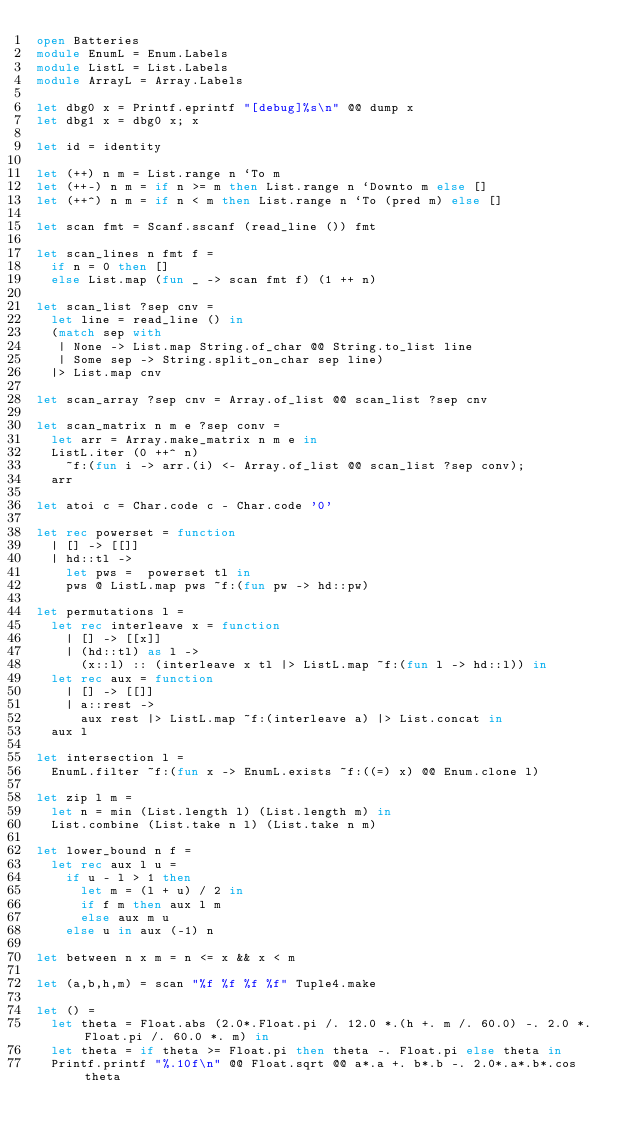Convert code to text. <code><loc_0><loc_0><loc_500><loc_500><_OCaml_>open Batteries
module EnumL = Enum.Labels
module ListL = List.Labels
module ArrayL = Array.Labels

let dbg0 x = Printf.eprintf "[debug]%s\n" @@ dump x
let dbg1 x = dbg0 x; x

let id = identity

let (++) n m = List.range n `To m
let (++-) n m = if n >= m then List.range n `Downto m else []
let (++^) n m = if n < m then List.range n `To (pred m) else []

let scan fmt = Scanf.sscanf (read_line ()) fmt

let scan_lines n fmt f =
  if n = 0 then []
  else List.map (fun _ -> scan fmt f) (1 ++ n)

let scan_list ?sep cnv =
  let line = read_line () in
  (match sep with
   | None -> List.map String.of_char @@ String.to_list line
   | Some sep -> String.split_on_char sep line)
  |> List.map cnv

let scan_array ?sep cnv = Array.of_list @@ scan_list ?sep cnv

let scan_matrix n m e ?sep conv =
  let arr = Array.make_matrix n m e in
  ListL.iter (0 ++^ n)
    ~f:(fun i -> arr.(i) <- Array.of_list @@ scan_list ?sep conv);
  arr

let atoi c = Char.code c - Char.code '0'

let rec powerset = function
  | [] -> [[]]
  | hd::tl ->
    let pws =  powerset tl in
    pws @ ListL.map pws ~f:(fun pw -> hd::pw)

let permutations l =
  let rec interleave x = function
    | [] -> [[x]]
    | (hd::tl) as l ->
      (x::l) :: (interleave x tl |> ListL.map ~f:(fun l -> hd::l)) in
  let rec aux = function
    | [] -> [[]]
    | a::rest ->
      aux rest |> ListL.map ~f:(interleave a) |> List.concat in
  aux l

let intersection l =
  EnumL.filter ~f:(fun x -> EnumL.exists ~f:((=) x) @@ Enum.clone l)

let zip l m =
  let n = min (List.length l) (List.length m) in
  List.combine (List.take n l) (List.take n m)

let lower_bound n f =
  let rec aux l u =
    if u - l > 1 then
      let m = (l + u) / 2 in
      if f m then aux l m
      else aux m u
    else u in aux (-1) n

let between n x m = n <= x && x < m

let (a,b,h,m) = scan "%f %f %f %f" Tuple4.make

let () =
  let theta = Float.abs (2.0*.Float.pi /. 12.0 *.(h +. m /. 60.0) -. 2.0 *. Float.pi /. 60.0 *. m) in
  let theta = if theta >= Float.pi then theta -. Float.pi else theta in
  Printf.printf "%.10f\n" @@ Float.sqrt @@ a*.a +. b*.b -. 2.0*.a*.b*.cos theta
</code> 